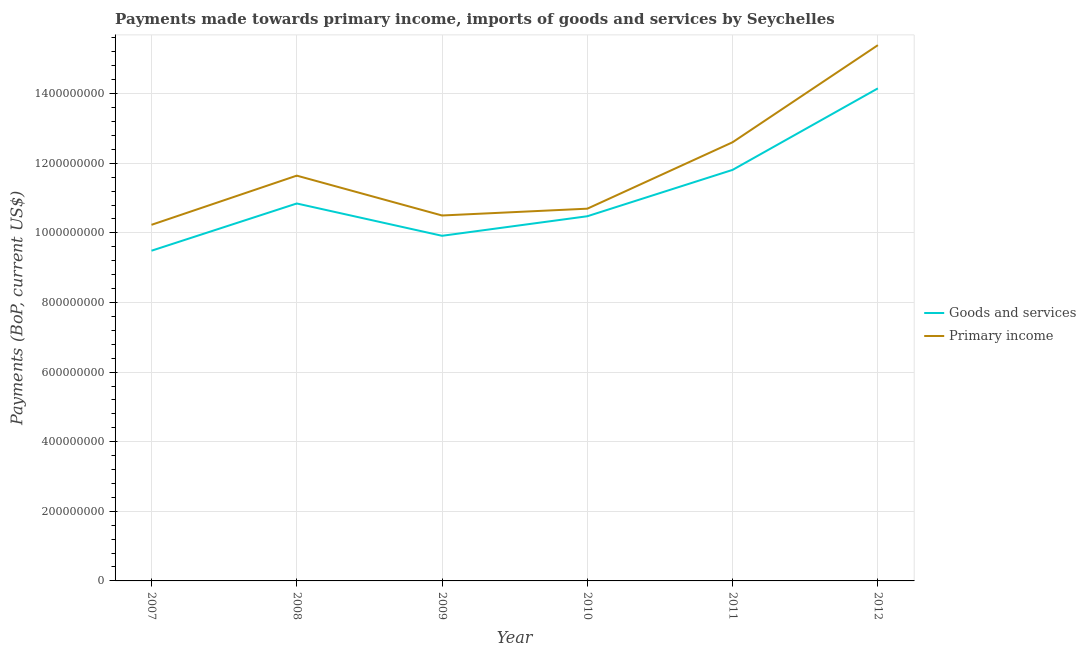How many different coloured lines are there?
Ensure brevity in your answer.  2. Does the line corresponding to payments made towards primary income intersect with the line corresponding to payments made towards goods and services?
Your answer should be compact. No. Is the number of lines equal to the number of legend labels?
Provide a short and direct response. Yes. What is the payments made towards goods and services in 2010?
Ensure brevity in your answer.  1.05e+09. Across all years, what is the maximum payments made towards primary income?
Provide a short and direct response. 1.54e+09. Across all years, what is the minimum payments made towards goods and services?
Your answer should be compact. 9.49e+08. In which year was the payments made towards primary income maximum?
Offer a terse response. 2012. What is the total payments made towards primary income in the graph?
Provide a succinct answer. 7.11e+09. What is the difference between the payments made towards primary income in 2008 and that in 2009?
Keep it short and to the point. 1.14e+08. What is the difference between the payments made towards goods and services in 2011 and the payments made towards primary income in 2009?
Your response must be concise. 1.31e+08. What is the average payments made towards primary income per year?
Give a very brief answer. 1.18e+09. In the year 2012, what is the difference between the payments made towards goods and services and payments made towards primary income?
Your answer should be very brief. -1.24e+08. What is the ratio of the payments made towards goods and services in 2010 to that in 2011?
Your response must be concise. 0.89. Is the payments made towards primary income in 2007 less than that in 2012?
Your answer should be very brief. Yes. Is the difference between the payments made towards goods and services in 2010 and 2012 greater than the difference between the payments made towards primary income in 2010 and 2012?
Offer a very short reply. Yes. What is the difference between the highest and the second highest payments made towards primary income?
Offer a very short reply. 2.79e+08. What is the difference between the highest and the lowest payments made towards goods and services?
Offer a very short reply. 4.66e+08. In how many years, is the payments made towards primary income greater than the average payments made towards primary income taken over all years?
Offer a terse response. 2. Is the sum of the payments made towards primary income in 2008 and 2011 greater than the maximum payments made towards goods and services across all years?
Make the answer very short. Yes. Does the payments made towards primary income monotonically increase over the years?
Your answer should be very brief. No. How many years are there in the graph?
Your response must be concise. 6. How many legend labels are there?
Your answer should be compact. 2. How are the legend labels stacked?
Make the answer very short. Vertical. What is the title of the graph?
Offer a very short reply. Payments made towards primary income, imports of goods and services by Seychelles. Does "Services" appear as one of the legend labels in the graph?
Your answer should be very brief. No. What is the label or title of the Y-axis?
Provide a succinct answer. Payments (BoP, current US$). What is the Payments (BoP, current US$) in Goods and services in 2007?
Your answer should be compact. 9.49e+08. What is the Payments (BoP, current US$) of Primary income in 2007?
Your answer should be very brief. 1.02e+09. What is the Payments (BoP, current US$) in Goods and services in 2008?
Offer a very short reply. 1.08e+09. What is the Payments (BoP, current US$) of Primary income in 2008?
Offer a terse response. 1.16e+09. What is the Payments (BoP, current US$) of Goods and services in 2009?
Your response must be concise. 9.92e+08. What is the Payments (BoP, current US$) in Primary income in 2009?
Provide a short and direct response. 1.05e+09. What is the Payments (BoP, current US$) in Goods and services in 2010?
Your answer should be compact. 1.05e+09. What is the Payments (BoP, current US$) of Primary income in 2010?
Give a very brief answer. 1.07e+09. What is the Payments (BoP, current US$) in Goods and services in 2011?
Provide a succinct answer. 1.18e+09. What is the Payments (BoP, current US$) of Primary income in 2011?
Provide a short and direct response. 1.26e+09. What is the Payments (BoP, current US$) of Goods and services in 2012?
Ensure brevity in your answer.  1.42e+09. What is the Payments (BoP, current US$) of Primary income in 2012?
Provide a succinct answer. 1.54e+09. Across all years, what is the maximum Payments (BoP, current US$) of Goods and services?
Your answer should be very brief. 1.42e+09. Across all years, what is the maximum Payments (BoP, current US$) in Primary income?
Your answer should be compact. 1.54e+09. Across all years, what is the minimum Payments (BoP, current US$) of Goods and services?
Offer a terse response. 9.49e+08. Across all years, what is the minimum Payments (BoP, current US$) of Primary income?
Your answer should be compact. 1.02e+09. What is the total Payments (BoP, current US$) of Goods and services in the graph?
Offer a terse response. 6.67e+09. What is the total Payments (BoP, current US$) in Primary income in the graph?
Your response must be concise. 7.11e+09. What is the difference between the Payments (BoP, current US$) in Goods and services in 2007 and that in 2008?
Keep it short and to the point. -1.36e+08. What is the difference between the Payments (BoP, current US$) of Primary income in 2007 and that in 2008?
Provide a short and direct response. -1.41e+08. What is the difference between the Payments (BoP, current US$) of Goods and services in 2007 and that in 2009?
Keep it short and to the point. -4.29e+07. What is the difference between the Payments (BoP, current US$) of Primary income in 2007 and that in 2009?
Offer a very short reply. -2.68e+07. What is the difference between the Payments (BoP, current US$) in Goods and services in 2007 and that in 2010?
Make the answer very short. -9.91e+07. What is the difference between the Payments (BoP, current US$) in Primary income in 2007 and that in 2010?
Your answer should be compact. -4.64e+07. What is the difference between the Payments (BoP, current US$) in Goods and services in 2007 and that in 2011?
Make the answer very short. -2.32e+08. What is the difference between the Payments (BoP, current US$) in Primary income in 2007 and that in 2011?
Offer a very short reply. -2.37e+08. What is the difference between the Payments (BoP, current US$) of Goods and services in 2007 and that in 2012?
Ensure brevity in your answer.  -4.66e+08. What is the difference between the Payments (BoP, current US$) of Primary income in 2007 and that in 2012?
Make the answer very short. -5.16e+08. What is the difference between the Payments (BoP, current US$) in Goods and services in 2008 and that in 2009?
Your answer should be compact. 9.28e+07. What is the difference between the Payments (BoP, current US$) in Primary income in 2008 and that in 2009?
Provide a succinct answer. 1.14e+08. What is the difference between the Payments (BoP, current US$) of Goods and services in 2008 and that in 2010?
Provide a short and direct response. 3.67e+07. What is the difference between the Payments (BoP, current US$) in Primary income in 2008 and that in 2010?
Provide a succinct answer. 9.49e+07. What is the difference between the Payments (BoP, current US$) in Goods and services in 2008 and that in 2011?
Offer a terse response. -9.66e+07. What is the difference between the Payments (BoP, current US$) in Primary income in 2008 and that in 2011?
Make the answer very short. -9.60e+07. What is the difference between the Payments (BoP, current US$) in Goods and services in 2008 and that in 2012?
Keep it short and to the point. -3.31e+08. What is the difference between the Payments (BoP, current US$) of Primary income in 2008 and that in 2012?
Keep it short and to the point. -3.75e+08. What is the difference between the Payments (BoP, current US$) in Goods and services in 2009 and that in 2010?
Make the answer very short. -5.62e+07. What is the difference between the Payments (BoP, current US$) of Primary income in 2009 and that in 2010?
Provide a short and direct response. -1.95e+07. What is the difference between the Payments (BoP, current US$) of Goods and services in 2009 and that in 2011?
Make the answer very short. -1.89e+08. What is the difference between the Payments (BoP, current US$) of Primary income in 2009 and that in 2011?
Make the answer very short. -2.10e+08. What is the difference between the Payments (BoP, current US$) in Goods and services in 2009 and that in 2012?
Keep it short and to the point. -4.24e+08. What is the difference between the Payments (BoP, current US$) of Primary income in 2009 and that in 2012?
Provide a succinct answer. -4.89e+08. What is the difference between the Payments (BoP, current US$) of Goods and services in 2010 and that in 2011?
Your answer should be compact. -1.33e+08. What is the difference between the Payments (BoP, current US$) in Primary income in 2010 and that in 2011?
Give a very brief answer. -1.91e+08. What is the difference between the Payments (BoP, current US$) in Goods and services in 2010 and that in 2012?
Offer a very short reply. -3.67e+08. What is the difference between the Payments (BoP, current US$) in Primary income in 2010 and that in 2012?
Provide a short and direct response. -4.70e+08. What is the difference between the Payments (BoP, current US$) in Goods and services in 2011 and that in 2012?
Provide a succinct answer. -2.34e+08. What is the difference between the Payments (BoP, current US$) of Primary income in 2011 and that in 2012?
Offer a very short reply. -2.79e+08. What is the difference between the Payments (BoP, current US$) of Goods and services in 2007 and the Payments (BoP, current US$) of Primary income in 2008?
Provide a short and direct response. -2.16e+08. What is the difference between the Payments (BoP, current US$) in Goods and services in 2007 and the Payments (BoP, current US$) in Primary income in 2009?
Give a very brief answer. -1.01e+08. What is the difference between the Payments (BoP, current US$) of Goods and services in 2007 and the Payments (BoP, current US$) of Primary income in 2010?
Provide a succinct answer. -1.21e+08. What is the difference between the Payments (BoP, current US$) of Goods and services in 2007 and the Payments (BoP, current US$) of Primary income in 2011?
Keep it short and to the point. -3.12e+08. What is the difference between the Payments (BoP, current US$) of Goods and services in 2007 and the Payments (BoP, current US$) of Primary income in 2012?
Your response must be concise. -5.91e+08. What is the difference between the Payments (BoP, current US$) of Goods and services in 2008 and the Payments (BoP, current US$) of Primary income in 2009?
Offer a very short reply. 3.45e+07. What is the difference between the Payments (BoP, current US$) of Goods and services in 2008 and the Payments (BoP, current US$) of Primary income in 2010?
Your answer should be very brief. 1.49e+07. What is the difference between the Payments (BoP, current US$) in Goods and services in 2008 and the Payments (BoP, current US$) in Primary income in 2011?
Give a very brief answer. -1.76e+08. What is the difference between the Payments (BoP, current US$) in Goods and services in 2008 and the Payments (BoP, current US$) in Primary income in 2012?
Your response must be concise. -4.55e+08. What is the difference between the Payments (BoP, current US$) of Goods and services in 2009 and the Payments (BoP, current US$) of Primary income in 2010?
Offer a very short reply. -7.79e+07. What is the difference between the Payments (BoP, current US$) of Goods and services in 2009 and the Payments (BoP, current US$) of Primary income in 2011?
Provide a short and direct response. -2.69e+08. What is the difference between the Payments (BoP, current US$) of Goods and services in 2009 and the Payments (BoP, current US$) of Primary income in 2012?
Keep it short and to the point. -5.48e+08. What is the difference between the Payments (BoP, current US$) in Goods and services in 2010 and the Payments (BoP, current US$) in Primary income in 2011?
Your answer should be compact. -2.13e+08. What is the difference between the Payments (BoP, current US$) of Goods and services in 2010 and the Payments (BoP, current US$) of Primary income in 2012?
Your response must be concise. -4.92e+08. What is the difference between the Payments (BoP, current US$) of Goods and services in 2011 and the Payments (BoP, current US$) of Primary income in 2012?
Your answer should be very brief. -3.58e+08. What is the average Payments (BoP, current US$) in Goods and services per year?
Keep it short and to the point. 1.11e+09. What is the average Payments (BoP, current US$) in Primary income per year?
Your response must be concise. 1.18e+09. In the year 2007, what is the difference between the Payments (BoP, current US$) of Goods and services and Payments (BoP, current US$) of Primary income?
Keep it short and to the point. -7.44e+07. In the year 2008, what is the difference between the Payments (BoP, current US$) in Goods and services and Payments (BoP, current US$) in Primary income?
Provide a short and direct response. -8.00e+07. In the year 2009, what is the difference between the Payments (BoP, current US$) in Goods and services and Payments (BoP, current US$) in Primary income?
Offer a very short reply. -5.84e+07. In the year 2010, what is the difference between the Payments (BoP, current US$) of Goods and services and Payments (BoP, current US$) of Primary income?
Your response must be concise. -2.17e+07. In the year 2011, what is the difference between the Payments (BoP, current US$) in Goods and services and Payments (BoP, current US$) in Primary income?
Your answer should be compact. -7.94e+07. In the year 2012, what is the difference between the Payments (BoP, current US$) of Goods and services and Payments (BoP, current US$) of Primary income?
Provide a short and direct response. -1.24e+08. What is the ratio of the Payments (BoP, current US$) in Goods and services in 2007 to that in 2008?
Make the answer very short. 0.87. What is the ratio of the Payments (BoP, current US$) in Primary income in 2007 to that in 2008?
Ensure brevity in your answer.  0.88. What is the ratio of the Payments (BoP, current US$) in Goods and services in 2007 to that in 2009?
Keep it short and to the point. 0.96. What is the ratio of the Payments (BoP, current US$) of Primary income in 2007 to that in 2009?
Provide a succinct answer. 0.97. What is the ratio of the Payments (BoP, current US$) of Goods and services in 2007 to that in 2010?
Give a very brief answer. 0.91. What is the ratio of the Payments (BoP, current US$) in Primary income in 2007 to that in 2010?
Give a very brief answer. 0.96. What is the ratio of the Payments (BoP, current US$) of Goods and services in 2007 to that in 2011?
Your answer should be very brief. 0.8. What is the ratio of the Payments (BoP, current US$) in Primary income in 2007 to that in 2011?
Your response must be concise. 0.81. What is the ratio of the Payments (BoP, current US$) of Goods and services in 2007 to that in 2012?
Keep it short and to the point. 0.67. What is the ratio of the Payments (BoP, current US$) in Primary income in 2007 to that in 2012?
Ensure brevity in your answer.  0.66. What is the ratio of the Payments (BoP, current US$) of Goods and services in 2008 to that in 2009?
Your answer should be compact. 1.09. What is the ratio of the Payments (BoP, current US$) of Primary income in 2008 to that in 2009?
Ensure brevity in your answer.  1.11. What is the ratio of the Payments (BoP, current US$) in Goods and services in 2008 to that in 2010?
Your answer should be very brief. 1.03. What is the ratio of the Payments (BoP, current US$) in Primary income in 2008 to that in 2010?
Ensure brevity in your answer.  1.09. What is the ratio of the Payments (BoP, current US$) in Goods and services in 2008 to that in 2011?
Provide a succinct answer. 0.92. What is the ratio of the Payments (BoP, current US$) of Primary income in 2008 to that in 2011?
Make the answer very short. 0.92. What is the ratio of the Payments (BoP, current US$) in Goods and services in 2008 to that in 2012?
Provide a succinct answer. 0.77. What is the ratio of the Payments (BoP, current US$) in Primary income in 2008 to that in 2012?
Your answer should be compact. 0.76. What is the ratio of the Payments (BoP, current US$) of Goods and services in 2009 to that in 2010?
Your answer should be very brief. 0.95. What is the ratio of the Payments (BoP, current US$) in Primary income in 2009 to that in 2010?
Provide a succinct answer. 0.98. What is the ratio of the Payments (BoP, current US$) in Goods and services in 2009 to that in 2011?
Provide a succinct answer. 0.84. What is the ratio of the Payments (BoP, current US$) of Primary income in 2009 to that in 2011?
Your answer should be very brief. 0.83. What is the ratio of the Payments (BoP, current US$) of Goods and services in 2009 to that in 2012?
Keep it short and to the point. 0.7. What is the ratio of the Payments (BoP, current US$) of Primary income in 2009 to that in 2012?
Keep it short and to the point. 0.68. What is the ratio of the Payments (BoP, current US$) in Goods and services in 2010 to that in 2011?
Your answer should be very brief. 0.89. What is the ratio of the Payments (BoP, current US$) of Primary income in 2010 to that in 2011?
Ensure brevity in your answer.  0.85. What is the ratio of the Payments (BoP, current US$) in Goods and services in 2010 to that in 2012?
Offer a very short reply. 0.74. What is the ratio of the Payments (BoP, current US$) of Primary income in 2010 to that in 2012?
Offer a terse response. 0.69. What is the ratio of the Payments (BoP, current US$) of Goods and services in 2011 to that in 2012?
Offer a terse response. 0.83. What is the ratio of the Payments (BoP, current US$) of Primary income in 2011 to that in 2012?
Give a very brief answer. 0.82. What is the difference between the highest and the second highest Payments (BoP, current US$) in Goods and services?
Make the answer very short. 2.34e+08. What is the difference between the highest and the second highest Payments (BoP, current US$) of Primary income?
Make the answer very short. 2.79e+08. What is the difference between the highest and the lowest Payments (BoP, current US$) of Goods and services?
Give a very brief answer. 4.66e+08. What is the difference between the highest and the lowest Payments (BoP, current US$) of Primary income?
Keep it short and to the point. 5.16e+08. 